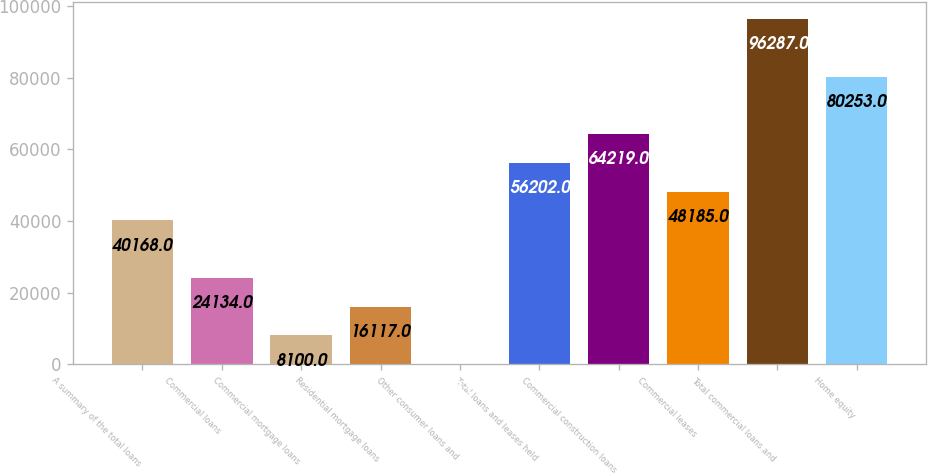Convert chart to OTSL. <chart><loc_0><loc_0><loc_500><loc_500><bar_chart><fcel>A summary of the total loans<fcel>Commercial loans<fcel>Commercial mortgage loans<fcel>Residential mortgage loans<fcel>Other consumer loans and<fcel>Total loans and leases held<fcel>Commercial construction loans<fcel>Commercial leases<fcel>Total commercial loans and<fcel>Home equity<nl><fcel>40168<fcel>24134<fcel>8100<fcel>16117<fcel>83<fcel>56202<fcel>64219<fcel>48185<fcel>96287<fcel>80253<nl></chart> 